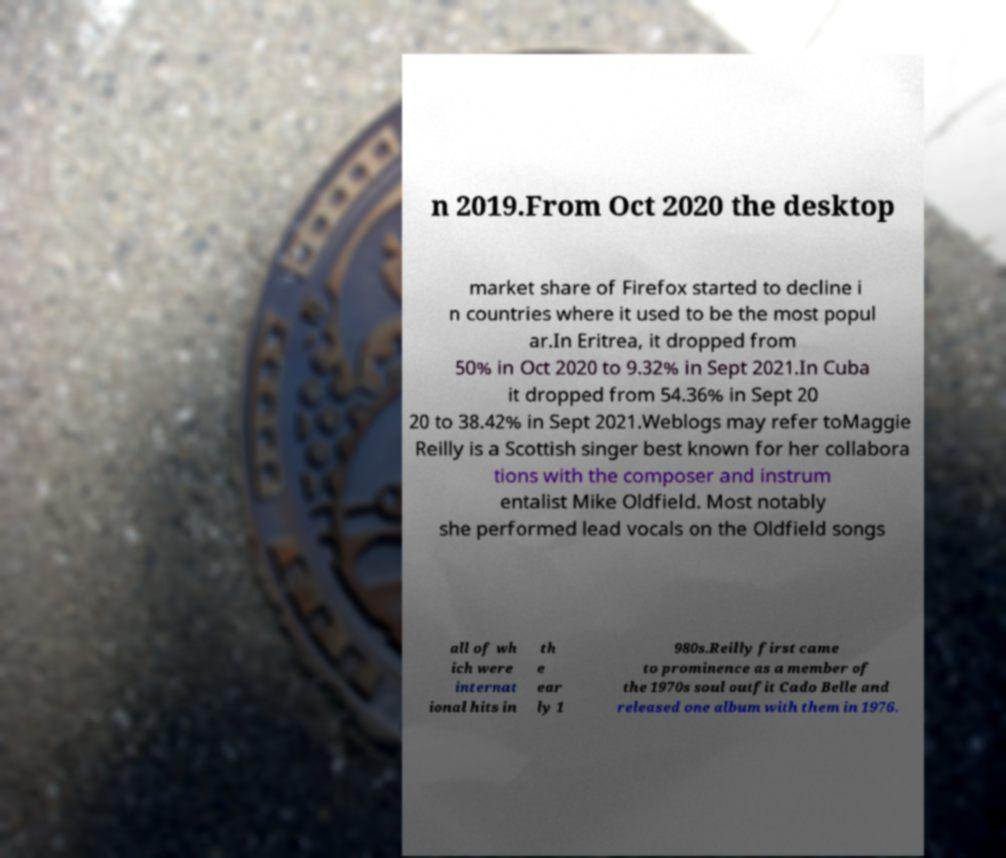Could you assist in decoding the text presented in this image and type it out clearly? n 2019.From Oct 2020 the desktop market share of Firefox started to decline i n countries where it used to be the most popul ar.In Eritrea, it dropped from 50% in Oct 2020 to 9.32% in Sept 2021.In Cuba it dropped from 54.36% in Sept 20 20 to 38.42% in Sept 2021.Weblogs may refer toMaggie Reilly is a Scottish singer best known for her collabora tions with the composer and instrum entalist Mike Oldfield. Most notably she performed lead vocals on the Oldfield songs all of wh ich were internat ional hits in th e ear ly 1 980s.Reilly first came to prominence as a member of the 1970s soul outfit Cado Belle and released one album with them in 1976. 